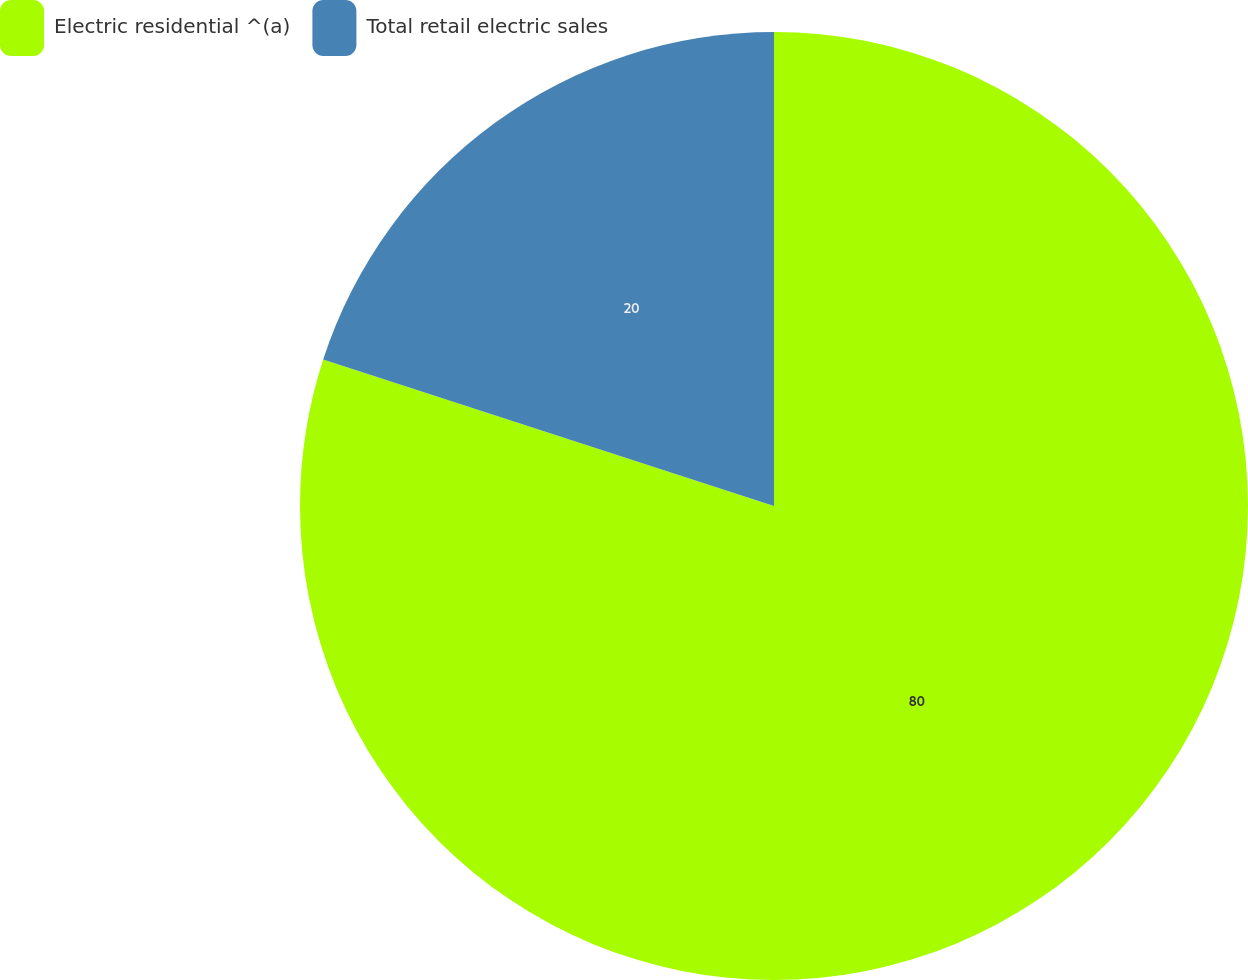Convert chart. <chart><loc_0><loc_0><loc_500><loc_500><pie_chart><fcel>Electric residential ^(a)<fcel>Total retail electric sales<nl><fcel>80.0%<fcel>20.0%<nl></chart> 